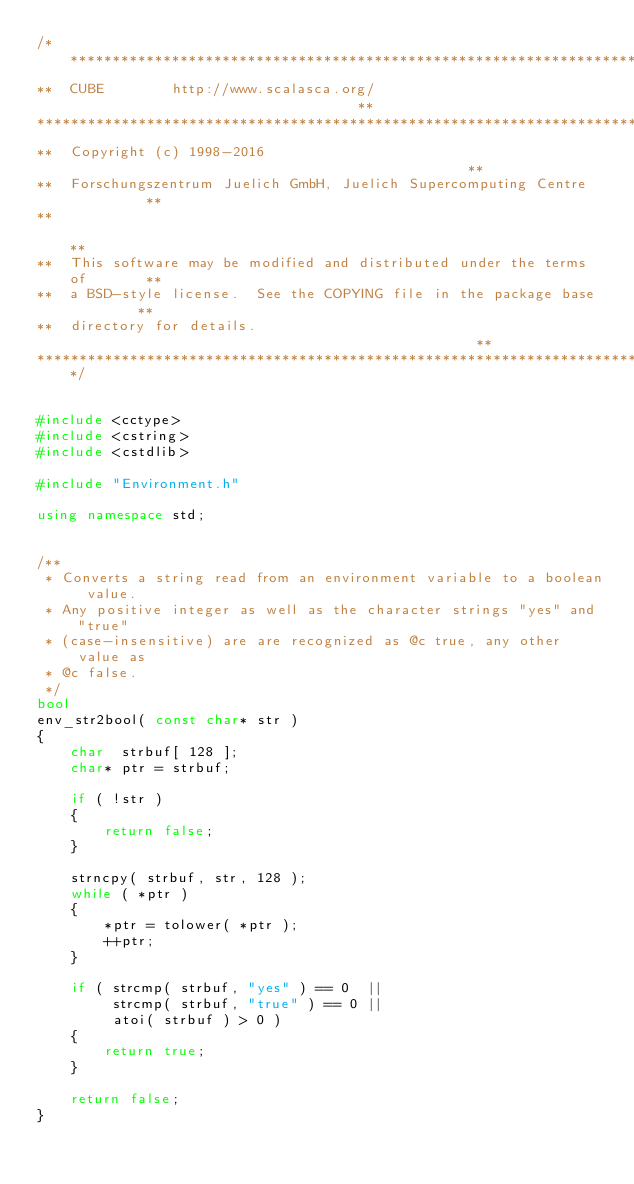<code> <loc_0><loc_0><loc_500><loc_500><_C++_>/****************************************************************************
**  CUBE        http://www.scalasca.org/                                   **
*****************************************************************************
**  Copyright (c) 1998-2016                                                **
**  Forschungszentrum Juelich GmbH, Juelich Supercomputing Centre          **
**                                                                         **
**  This software may be modified and distributed under the terms of       **
**  a BSD-style license.  See the COPYING file in the package base         **
**  directory for details.                                                 **
****************************************************************************/


#include <cctype>
#include <cstring>
#include <cstdlib>

#include "Environment.h"

using namespace std;


/**
 * Converts a string read from an environment variable to a boolean value.
 * Any positive integer as well as the character strings "yes" and "true"
 * (case-insensitive) are are recognized as @c true, any other value as
 * @c false.
 */
bool
env_str2bool( const char* str )
{
    char  strbuf[ 128 ];
    char* ptr = strbuf;

    if ( !str )
    {
        return false;
    }

    strncpy( strbuf, str, 128 );
    while ( *ptr )
    {
        *ptr = tolower( *ptr );
        ++ptr;
    }

    if ( strcmp( strbuf, "yes" ) == 0  ||
         strcmp( strbuf, "true" ) == 0 ||
         atoi( strbuf ) > 0 )
    {
        return true;
    }

    return false;
}
</code> 